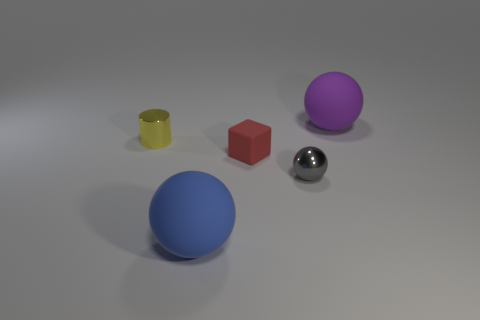There is a purple matte thing that is the same shape as the gray metal object; what size is it?
Keep it short and to the point. Large. What number of things are tiny red rubber cubes that are behind the tiny gray metal sphere or red blocks?
Your answer should be compact. 1. What color is the other large sphere that is made of the same material as the blue sphere?
Keep it short and to the point. Purple. Is there a purple thing that has the same size as the metallic cylinder?
Provide a short and direct response. No. What number of things are tiny gray objects that are behind the large blue rubber ball or rubber objects in front of the large purple rubber thing?
Ensure brevity in your answer.  3. What is the shape of the blue rubber object that is the same size as the purple matte thing?
Your response must be concise. Sphere. Is there a small yellow metal object of the same shape as the big purple rubber object?
Provide a short and direct response. No. Is the number of small objects less than the number of tiny red rubber objects?
Give a very brief answer. No. There is a rubber sphere that is behind the red object; is it the same size as the matte sphere that is in front of the large purple object?
Your answer should be very brief. Yes. What number of things are either yellow shiny cylinders or blue rubber cubes?
Offer a terse response. 1. 